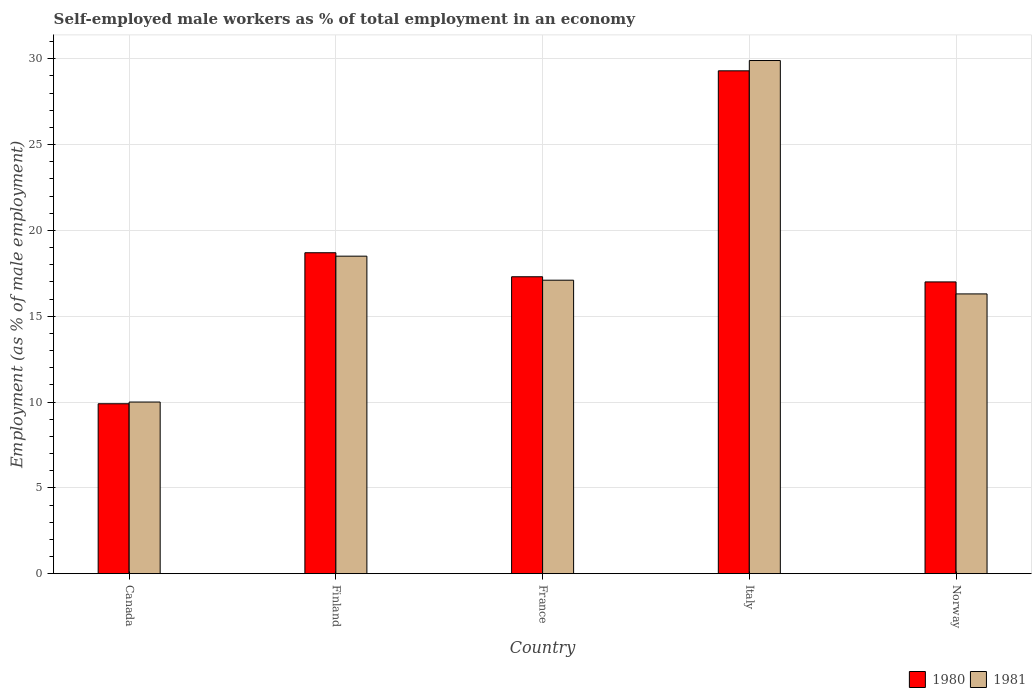How many different coloured bars are there?
Provide a short and direct response. 2. Are the number of bars on each tick of the X-axis equal?
Offer a very short reply. Yes. What is the label of the 1st group of bars from the left?
Your response must be concise. Canada. What is the percentage of self-employed male workers in 1981 in France?
Your answer should be very brief. 17.1. Across all countries, what is the maximum percentage of self-employed male workers in 1980?
Your answer should be compact. 29.3. Across all countries, what is the minimum percentage of self-employed male workers in 1981?
Your answer should be very brief. 10. What is the total percentage of self-employed male workers in 1980 in the graph?
Your response must be concise. 92.2. What is the difference between the percentage of self-employed male workers in 1980 in Canada and that in Norway?
Ensure brevity in your answer.  -7.1. What is the difference between the percentage of self-employed male workers in 1981 in Finland and the percentage of self-employed male workers in 1980 in Canada?
Offer a very short reply. 8.6. What is the average percentage of self-employed male workers in 1981 per country?
Provide a succinct answer. 18.36. What is the difference between the percentage of self-employed male workers of/in 1980 and percentage of self-employed male workers of/in 1981 in Italy?
Your answer should be compact. -0.6. What is the ratio of the percentage of self-employed male workers in 1980 in Italy to that in Norway?
Offer a terse response. 1.72. What is the difference between the highest and the second highest percentage of self-employed male workers in 1981?
Your response must be concise. -1.4. What is the difference between the highest and the lowest percentage of self-employed male workers in 1981?
Provide a succinct answer. 19.9. In how many countries, is the percentage of self-employed male workers in 1981 greater than the average percentage of self-employed male workers in 1981 taken over all countries?
Provide a succinct answer. 2. What does the 2nd bar from the left in Canada represents?
Offer a terse response. 1981. What does the 2nd bar from the right in Norway represents?
Offer a terse response. 1980. What is the difference between two consecutive major ticks on the Y-axis?
Give a very brief answer. 5. Does the graph contain grids?
Your answer should be very brief. Yes. How many legend labels are there?
Provide a succinct answer. 2. How are the legend labels stacked?
Keep it short and to the point. Horizontal. What is the title of the graph?
Make the answer very short. Self-employed male workers as % of total employment in an economy. What is the label or title of the Y-axis?
Offer a very short reply. Employment (as % of male employment). What is the Employment (as % of male employment) in 1980 in Canada?
Ensure brevity in your answer.  9.9. What is the Employment (as % of male employment) of 1981 in Canada?
Give a very brief answer. 10. What is the Employment (as % of male employment) of 1980 in Finland?
Offer a very short reply. 18.7. What is the Employment (as % of male employment) in 1981 in Finland?
Ensure brevity in your answer.  18.5. What is the Employment (as % of male employment) of 1980 in France?
Your answer should be very brief. 17.3. What is the Employment (as % of male employment) of 1981 in France?
Keep it short and to the point. 17.1. What is the Employment (as % of male employment) of 1980 in Italy?
Your answer should be very brief. 29.3. What is the Employment (as % of male employment) in 1981 in Italy?
Your response must be concise. 29.9. What is the Employment (as % of male employment) in 1980 in Norway?
Your answer should be very brief. 17. What is the Employment (as % of male employment) in 1981 in Norway?
Your response must be concise. 16.3. Across all countries, what is the maximum Employment (as % of male employment) of 1980?
Offer a terse response. 29.3. Across all countries, what is the maximum Employment (as % of male employment) of 1981?
Offer a very short reply. 29.9. Across all countries, what is the minimum Employment (as % of male employment) of 1980?
Your answer should be compact. 9.9. Across all countries, what is the minimum Employment (as % of male employment) of 1981?
Your response must be concise. 10. What is the total Employment (as % of male employment) in 1980 in the graph?
Your response must be concise. 92.2. What is the total Employment (as % of male employment) in 1981 in the graph?
Offer a terse response. 91.8. What is the difference between the Employment (as % of male employment) in 1980 in Canada and that in France?
Give a very brief answer. -7.4. What is the difference between the Employment (as % of male employment) in 1980 in Canada and that in Italy?
Ensure brevity in your answer.  -19.4. What is the difference between the Employment (as % of male employment) in 1981 in Canada and that in Italy?
Your answer should be very brief. -19.9. What is the difference between the Employment (as % of male employment) in 1981 in Canada and that in Norway?
Give a very brief answer. -6.3. What is the difference between the Employment (as % of male employment) of 1981 in Finland and that in Italy?
Make the answer very short. -11.4. What is the difference between the Employment (as % of male employment) in 1980 in Finland and that in Norway?
Keep it short and to the point. 1.7. What is the difference between the Employment (as % of male employment) in 1981 in Finland and that in Norway?
Keep it short and to the point. 2.2. What is the difference between the Employment (as % of male employment) in 1981 in France and that in Italy?
Provide a succinct answer. -12.8. What is the difference between the Employment (as % of male employment) in 1980 in France and that in Norway?
Ensure brevity in your answer.  0.3. What is the difference between the Employment (as % of male employment) of 1980 in Italy and that in Norway?
Your answer should be very brief. 12.3. What is the difference between the Employment (as % of male employment) in 1980 in Canada and the Employment (as % of male employment) in 1981 in Norway?
Your answer should be compact. -6.4. What is the difference between the Employment (as % of male employment) in 1980 in Finland and the Employment (as % of male employment) in 1981 in France?
Provide a succinct answer. 1.6. What is the difference between the Employment (as % of male employment) in 1980 in Italy and the Employment (as % of male employment) in 1981 in Norway?
Provide a short and direct response. 13. What is the average Employment (as % of male employment) in 1980 per country?
Ensure brevity in your answer.  18.44. What is the average Employment (as % of male employment) of 1981 per country?
Provide a short and direct response. 18.36. What is the difference between the Employment (as % of male employment) of 1980 and Employment (as % of male employment) of 1981 in Finland?
Your answer should be compact. 0.2. What is the difference between the Employment (as % of male employment) of 1980 and Employment (as % of male employment) of 1981 in France?
Your response must be concise. 0.2. What is the difference between the Employment (as % of male employment) in 1980 and Employment (as % of male employment) in 1981 in Italy?
Offer a terse response. -0.6. What is the difference between the Employment (as % of male employment) of 1980 and Employment (as % of male employment) of 1981 in Norway?
Your response must be concise. 0.7. What is the ratio of the Employment (as % of male employment) of 1980 in Canada to that in Finland?
Your answer should be compact. 0.53. What is the ratio of the Employment (as % of male employment) in 1981 in Canada to that in Finland?
Your answer should be very brief. 0.54. What is the ratio of the Employment (as % of male employment) in 1980 in Canada to that in France?
Provide a short and direct response. 0.57. What is the ratio of the Employment (as % of male employment) in 1981 in Canada to that in France?
Provide a short and direct response. 0.58. What is the ratio of the Employment (as % of male employment) in 1980 in Canada to that in Italy?
Keep it short and to the point. 0.34. What is the ratio of the Employment (as % of male employment) of 1981 in Canada to that in Italy?
Offer a terse response. 0.33. What is the ratio of the Employment (as % of male employment) of 1980 in Canada to that in Norway?
Offer a very short reply. 0.58. What is the ratio of the Employment (as % of male employment) of 1981 in Canada to that in Norway?
Ensure brevity in your answer.  0.61. What is the ratio of the Employment (as % of male employment) in 1980 in Finland to that in France?
Provide a succinct answer. 1.08. What is the ratio of the Employment (as % of male employment) in 1981 in Finland to that in France?
Provide a short and direct response. 1.08. What is the ratio of the Employment (as % of male employment) of 1980 in Finland to that in Italy?
Give a very brief answer. 0.64. What is the ratio of the Employment (as % of male employment) in 1981 in Finland to that in Italy?
Give a very brief answer. 0.62. What is the ratio of the Employment (as % of male employment) of 1981 in Finland to that in Norway?
Provide a succinct answer. 1.14. What is the ratio of the Employment (as % of male employment) of 1980 in France to that in Italy?
Keep it short and to the point. 0.59. What is the ratio of the Employment (as % of male employment) in 1981 in France to that in Italy?
Your answer should be very brief. 0.57. What is the ratio of the Employment (as % of male employment) in 1980 in France to that in Norway?
Make the answer very short. 1.02. What is the ratio of the Employment (as % of male employment) in 1981 in France to that in Norway?
Offer a very short reply. 1.05. What is the ratio of the Employment (as % of male employment) of 1980 in Italy to that in Norway?
Make the answer very short. 1.72. What is the ratio of the Employment (as % of male employment) in 1981 in Italy to that in Norway?
Your response must be concise. 1.83. What is the difference between the highest and the lowest Employment (as % of male employment) of 1980?
Your response must be concise. 19.4. What is the difference between the highest and the lowest Employment (as % of male employment) of 1981?
Your answer should be compact. 19.9. 